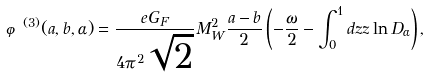<formula> <loc_0><loc_0><loc_500><loc_500>\varphi ^ { ( 3 ) } ( a , b , \alpha ) = { \frac { e G _ { F } } { 4 \pi ^ { 2 } \sqrt { 2 } } } M _ { W } ^ { 2 } { \frac { a - b } { 2 } } \left ( - { \frac { \omega } { 2 } } - \int _ { 0 } ^ { 1 } d z z \ln D _ { \alpha } \right ) ,</formula> 